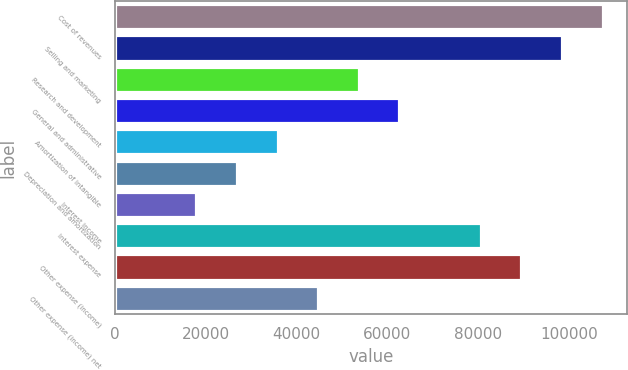Convert chart to OTSL. <chart><loc_0><loc_0><loc_500><loc_500><bar_chart><fcel>Cost of revenues<fcel>Selling and marketing<fcel>Research and development<fcel>General and administrative<fcel>Amortization of intangible<fcel>Depreciation and amortization<fcel>Interest income<fcel>Interest expense<fcel>Other expense (income)<fcel>Other expense (income) net<nl><fcel>107394<fcel>98444.3<fcel>53697.7<fcel>62647<fcel>35799<fcel>26849.7<fcel>17900.4<fcel>80545.7<fcel>89495<fcel>44748.3<nl></chart> 